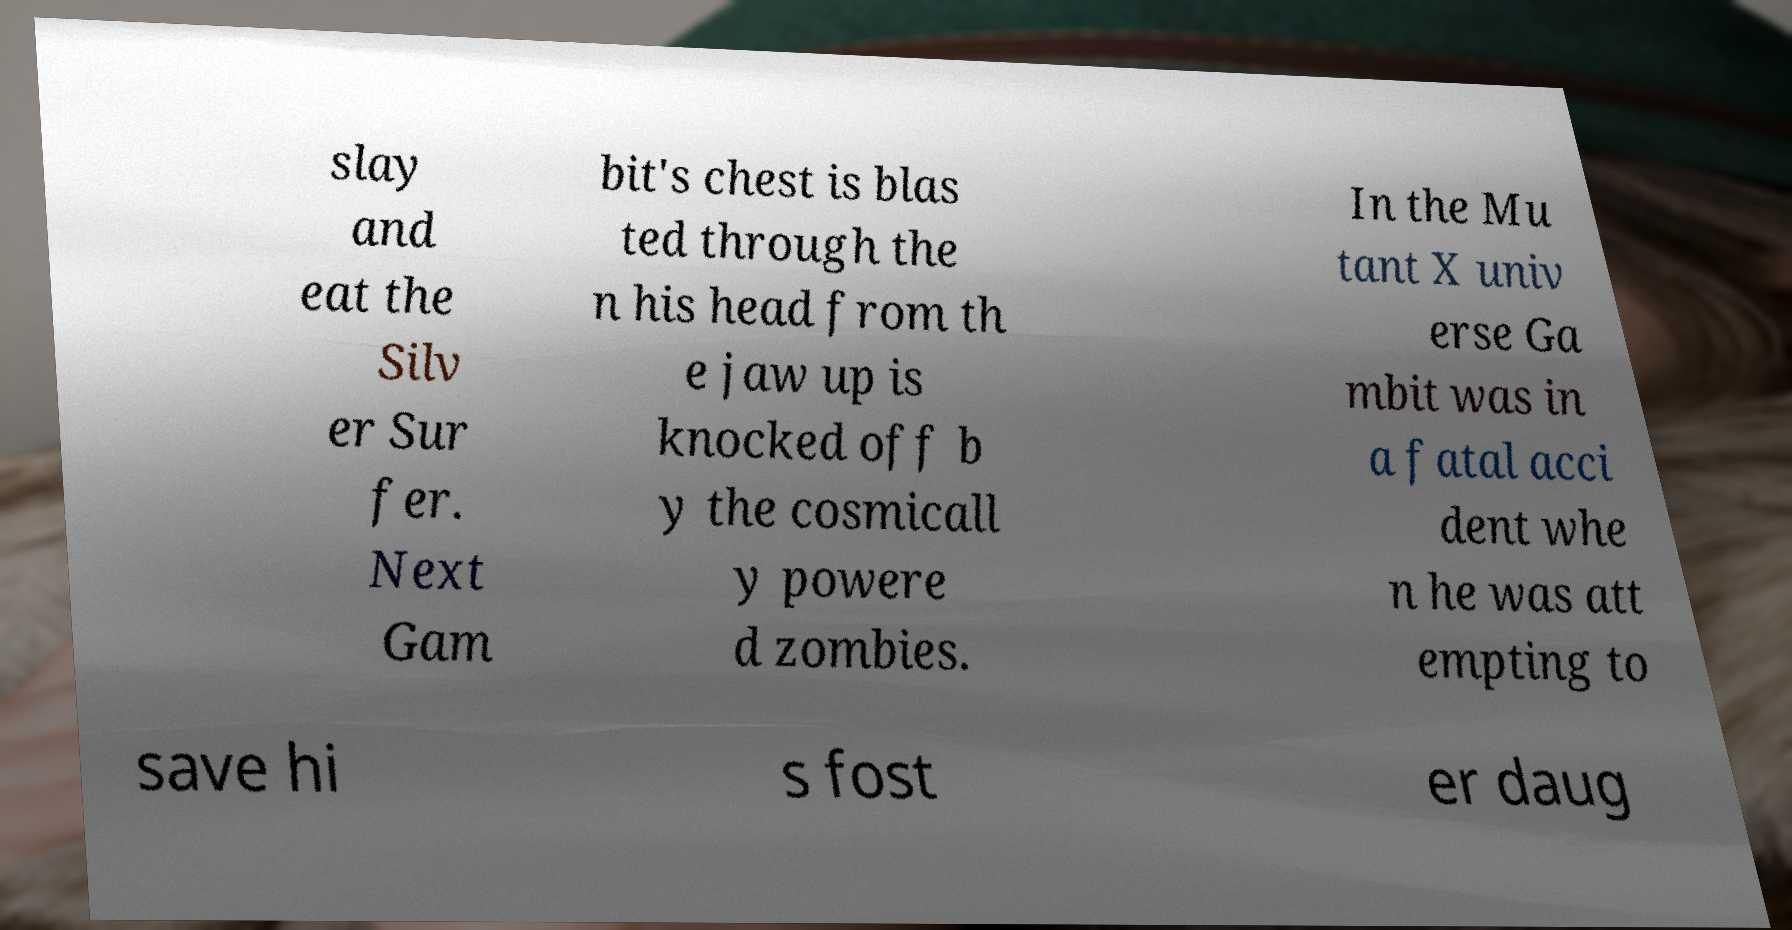Can you read and provide the text displayed in the image?This photo seems to have some interesting text. Can you extract and type it out for me? slay and eat the Silv er Sur fer. Next Gam bit's chest is blas ted through the n his head from th e jaw up is knocked off b y the cosmicall y powere d zombies. In the Mu tant X univ erse Ga mbit was in a fatal acci dent whe n he was att empting to save hi s fost er daug 